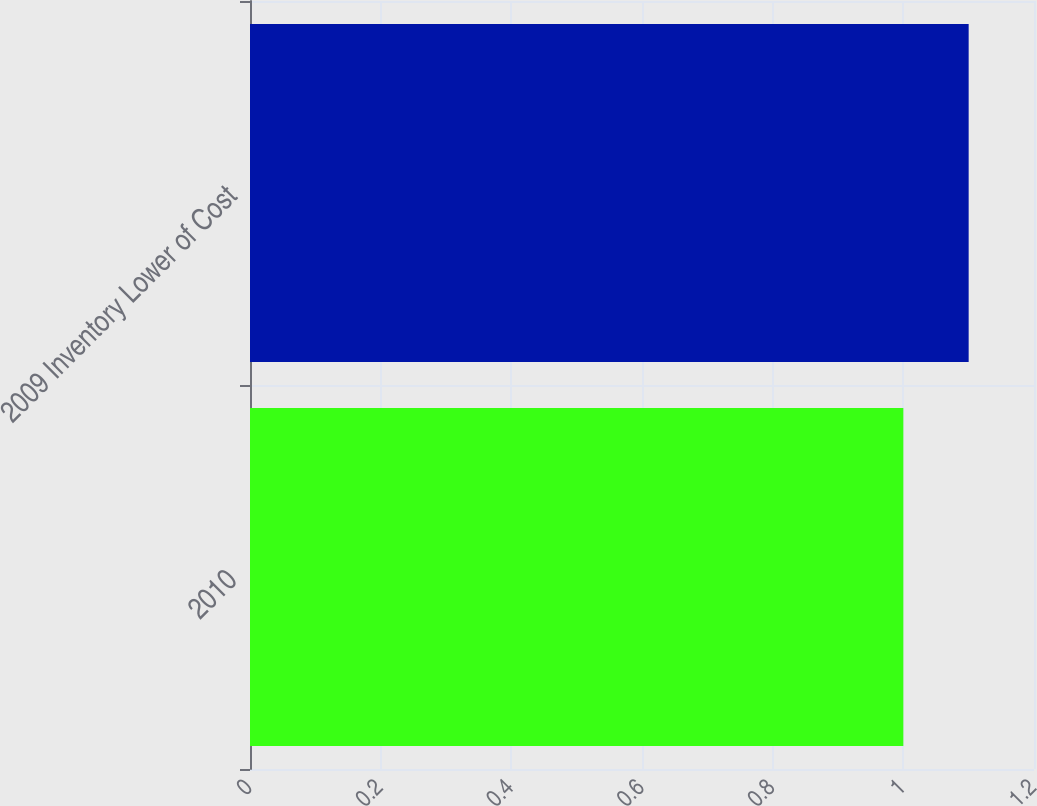Convert chart to OTSL. <chart><loc_0><loc_0><loc_500><loc_500><bar_chart><fcel>2010<fcel>2009 Inventory Lower of Cost<nl><fcel>1<fcel>1.1<nl></chart> 